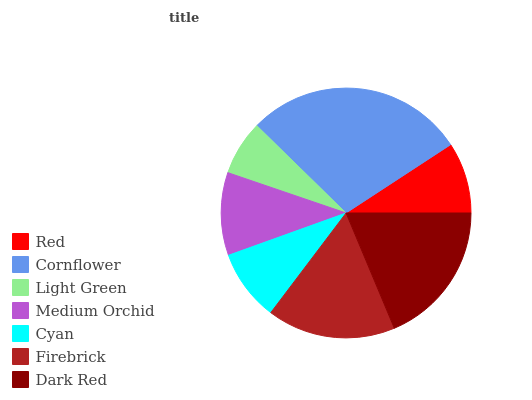Is Light Green the minimum?
Answer yes or no. Yes. Is Cornflower the maximum?
Answer yes or no. Yes. Is Cornflower the minimum?
Answer yes or no. No. Is Light Green the maximum?
Answer yes or no. No. Is Cornflower greater than Light Green?
Answer yes or no. Yes. Is Light Green less than Cornflower?
Answer yes or no. Yes. Is Light Green greater than Cornflower?
Answer yes or no. No. Is Cornflower less than Light Green?
Answer yes or no. No. Is Medium Orchid the high median?
Answer yes or no. Yes. Is Medium Orchid the low median?
Answer yes or no. Yes. Is Red the high median?
Answer yes or no. No. Is Cornflower the low median?
Answer yes or no. No. 